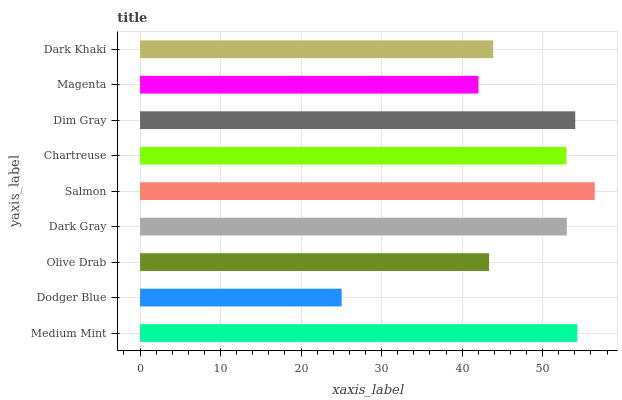Is Dodger Blue the minimum?
Answer yes or no. Yes. Is Salmon the maximum?
Answer yes or no. Yes. Is Olive Drab the minimum?
Answer yes or no. No. Is Olive Drab the maximum?
Answer yes or no. No. Is Olive Drab greater than Dodger Blue?
Answer yes or no. Yes. Is Dodger Blue less than Olive Drab?
Answer yes or no. Yes. Is Dodger Blue greater than Olive Drab?
Answer yes or no. No. Is Olive Drab less than Dodger Blue?
Answer yes or no. No. Is Chartreuse the high median?
Answer yes or no. Yes. Is Chartreuse the low median?
Answer yes or no. Yes. Is Dodger Blue the high median?
Answer yes or no. No. Is Dark Khaki the low median?
Answer yes or no. No. 